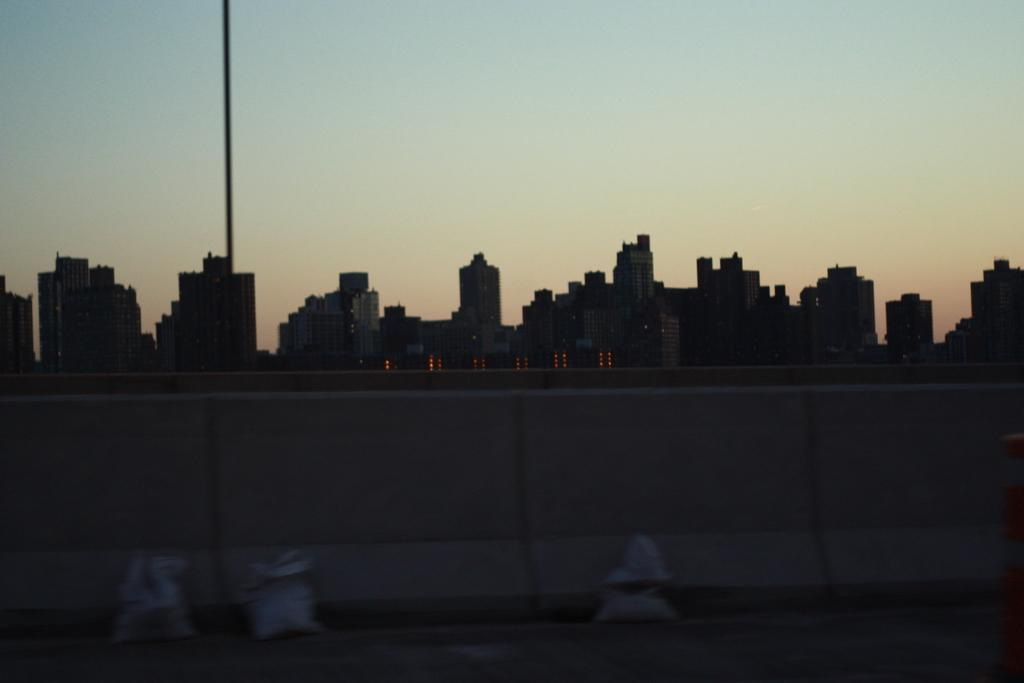What are the three white objects in the image? There are three white objects in the image, but their specific nature is not mentioned in the facts. What is located at the front of the image? There is a wall in the front of the image. What can be seen in the background of the image? In the background of the image, there is a pole, multiple buildings, lights, and the sky. Where is the map located in the image? There is no map present in the image. What type of observation can be made about the lights in the image? The facts do not provide any information about the nature of the lights or any observations that can be made about them. 